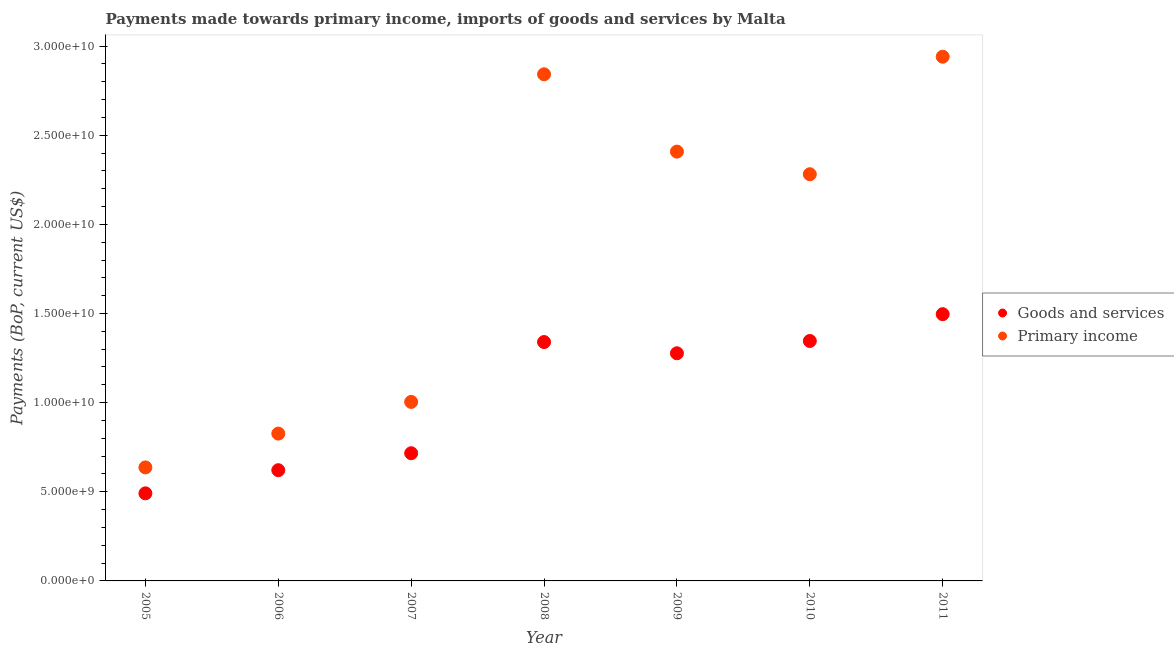Is the number of dotlines equal to the number of legend labels?
Make the answer very short. Yes. What is the payments made towards goods and services in 2008?
Ensure brevity in your answer.  1.34e+1. Across all years, what is the maximum payments made towards goods and services?
Offer a terse response. 1.50e+1. Across all years, what is the minimum payments made towards primary income?
Offer a terse response. 6.37e+09. In which year was the payments made towards primary income minimum?
Ensure brevity in your answer.  2005. What is the total payments made towards goods and services in the graph?
Provide a succinct answer. 7.29e+1. What is the difference between the payments made towards goods and services in 2005 and that in 2008?
Your answer should be very brief. -8.49e+09. What is the difference between the payments made towards goods and services in 2011 and the payments made towards primary income in 2007?
Ensure brevity in your answer.  4.92e+09. What is the average payments made towards goods and services per year?
Keep it short and to the point. 1.04e+1. In the year 2006, what is the difference between the payments made towards goods and services and payments made towards primary income?
Ensure brevity in your answer.  -2.05e+09. In how many years, is the payments made towards primary income greater than 17000000000 US$?
Offer a terse response. 4. What is the ratio of the payments made towards primary income in 2005 to that in 2010?
Keep it short and to the point. 0.28. What is the difference between the highest and the second highest payments made towards goods and services?
Your answer should be very brief. 1.50e+09. What is the difference between the highest and the lowest payments made towards goods and services?
Your answer should be compact. 1.00e+1. In how many years, is the payments made towards primary income greater than the average payments made towards primary income taken over all years?
Offer a very short reply. 4. Is the payments made towards primary income strictly greater than the payments made towards goods and services over the years?
Your response must be concise. Yes. Is the payments made towards goods and services strictly less than the payments made towards primary income over the years?
Ensure brevity in your answer.  Yes. Does the graph contain any zero values?
Your response must be concise. No. Does the graph contain grids?
Keep it short and to the point. No. Where does the legend appear in the graph?
Your response must be concise. Center right. How many legend labels are there?
Ensure brevity in your answer.  2. How are the legend labels stacked?
Keep it short and to the point. Vertical. What is the title of the graph?
Ensure brevity in your answer.  Payments made towards primary income, imports of goods and services by Malta. Does "Official aid received" appear as one of the legend labels in the graph?
Ensure brevity in your answer.  No. What is the label or title of the Y-axis?
Your answer should be very brief. Payments (BoP, current US$). What is the Payments (BoP, current US$) in Goods and services in 2005?
Your answer should be compact. 4.91e+09. What is the Payments (BoP, current US$) in Primary income in 2005?
Keep it short and to the point. 6.37e+09. What is the Payments (BoP, current US$) in Goods and services in 2006?
Ensure brevity in your answer.  6.21e+09. What is the Payments (BoP, current US$) in Primary income in 2006?
Offer a terse response. 8.26e+09. What is the Payments (BoP, current US$) of Goods and services in 2007?
Your answer should be compact. 7.16e+09. What is the Payments (BoP, current US$) of Primary income in 2007?
Offer a very short reply. 1.00e+1. What is the Payments (BoP, current US$) in Goods and services in 2008?
Keep it short and to the point. 1.34e+1. What is the Payments (BoP, current US$) of Primary income in 2008?
Give a very brief answer. 2.84e+1. What is the Payments (BoP, current US$) of Goods and services in 2009?
Offer a very short reply. 1.28e+1. What is the Payments (BoP, current US$) in Primary income in 2009?
Keep it short and to the point. 2.41e+1. What is the Payments (BoP, current US$) in Goods and services in 2010?
Keep it short and to the point. 1.35e+1. What is the Payments (BoP, current US$) of Primary income in 2010?
Your answer should be very brief. 2.28e+1. What is the Payments (BoP, current US$) in Goods and services in 2011?
Your answer should be compact. 1.50e+1. What is the Payments (BoP, current US$) in Primary income in 2011?
Provide a succinct answer. 2.94e+1. Across all years, what is the maximum Payments (BoP, current US$) of Goods and services?
Give a very brief answer. 1.50e+1. Across all years, what is the maximum Payments (BoP, current US$) in Primary income?
Provide a short and direct response. 2.94e+1. Across all years, what is the minimum Payments (BoP, current US$) of Goods and services?
Provide a succinct answer. 4.91e+09. Across all years, what is the minimum Payments (BoP, current US$) of Primary income?
Offer a terse response. 6.37e+09. What is the total Payments (BoP, current US$) of Goods and services in the graph?
Your response must be concise. 7.29e+1. What is the total Payments (BoP, current US$) of Primary income in the graph?
Give a very brief answer. 1.29e+11. What is the difference between the Payments (BoP, current US$) of Goods and services in 2005 and that in 2006?
Offer a terse response. -1.30e+09. What is the difference between the Payments (BoP, current US$) of Primary income in 2005 and that in 2006?
Your response must be concise. -1.90e+09. What is the difference between the Payments (BoP, current US$) in Goods and services in 2005 and that in 2007?
Make the answer very short. -2.25e+09. What is the difference between the Payments (BoP, current US$) of Primary income in 2005 and that in 2007?
Give a very brief answer. -3.67e+09. What is the difference between the Payments (BoP, current US$) in Goods and services in 2005 and that in 2008?
Provide a short and direct response. -8.49e+09. What is the difference between the Payments (BoP, current US$) of Primary income in 2005 and that in 2008?
Offer a very short reply. -2.21e+1. What is the difference between the Payments (BoP, current US$) in Goods and services in 2005 and that in 2009?
Provide a short and direct response. -7.86e+09. What is the difference between the Payments (BoP, current US$) of Primary income in 2005 and that in 2009?
Keep it short and to the point. -1.77e+1. What is the difference between the Payments (BoP, current US$) in Goods and services in 2005 and that in 2010?
Offer a terse response. -8.55e+09. What is the difference between the Payments (BoP, current US$) in Primary income in 2005 and that in 2010?
Your answer should be very brief. -1.64e+1. What is the difference between the Payments (BoP, current US$) in Goods and services in 2005 and that in 2011?
Provide a succinct answer. -1.00e+1. What is the difference between the Payments (BoP, current US$) of Primary income in 2005 and that in 2011?
Your answer should be compact. -2.30e+1. What is the difference between the Payments (BoP, current US$) in Goods and services in 2006 and that in 2007?
Your answer should be very brief. -9.52e+08. What is the difference between the Payments (BoP, current US$) of Primary income in 2006 and that in 2007?
Ensure brevity in your answer.  -1.78e+09. What is the difference between the Payments (BoP, current US$) in Goods and services in 2006 and that in 2008?
Provide a succinct answer. -7.19e+09. What is the difference between the Payments (BoP, current US$) in Primary income in 2006 and that in 2008?
Your answer should be very brief. -2.02e+1. What is the difference between the Payments (BoP, current US$) of Goods and services in 2006 and that in 2009?
Offer a terse response. -6.56e+09. What is the difference between the Payments (BoP, current US$) in Primary income in 2006 and that in 2009?
Make the answer very short. -1.58e+1. What is the difference between the Payments (BoP, current US$) of Goods and services in 2006 and that in 2010?
Offer a very short reply. -7.25e+09. What is the difference between the Payments (BoP, current US$) in Primary income in 2006 and that in 2010?
Offer a terse response. -1.45e+1. What is the difference between the Payments (BoP, current US$) of Goods and services in 2006 and that in 2011?
Offer a terse response. -8.75e+09. What is the difference between the Payments (BoP, current US$) in Primary income in 2006 and that in 2011?
Your response must be concise. -2.11e+1. What is the difference between the Payments (BoP, current US$) in Goods and services in 2007 and that in 2008?
Give a very brief answer. -6.24e+09. What is the difference between the Payments (BoP, current US$) of Primary income in 2007 and that in 2008?
Offer a terse response. -1.84e+1. What is the difference between the Payments (BoP, current US$) of Goods and services in 2007 and that in 2009?
Ensure brevity in your answer.  -5.61e+09. What is the difference between the Payments (BoP, current US$) in Primary income in 2007 and that in 2009?
Make the answer very short. -1.40e+1. What is the difference between the Payments (BoP, current US$) in Goods and services in 2007 and that in 2010?
Offer a very short reply. -6.30e+09. What is the difference between the Payments (BoP, current US$) of Primary income in 2007 and that in 2010?
Keep it short and to the point. -1.28e+1. What is the difference between the Payments (BoP, current US$) of Goods and services in 2007 and that in 2011?
Give a very brief answer. -7.80e+09. What is the difference between the Payments (BoP, current US$) of Primary income in 2007 and that in 2011?
Ensure brevity in your answer.  -1.94e+1. What is the difference between the Payments (BoP, current US$) of Goods and services in 2008 and that in 2009?
Ensure brevity in your answer.  6.31e+08. What is the difference between the Payments (BoP, current US$) of Primary income in 2008 and that in 2009?
Your response must be concise. 4.34e+09. What is the difference between the Payments (BoP, current US$) in Goods and services in 2008 and that in 2010?
Your response must be concise. -5.88e+07. What is the difference between the Payments (BoP, current US$) of Primary income in 2008 and that in 2010?
Provide a short and direct response. 5.61e+09. What is the difference between the Payments (BoP, current US$) in Goods and services in 2008 and that in 2011?
Your answer should be very brief. -1.56e+09. What is the difference between the Payments (BoP, current US$) in Primary income in 2008 and that in 2011?
Ensure brevity in your answer.  -9.86e+08. What is the difference between the Payments (BoP, current US$) in Goods and services in 2009 and that in 2010?
Ensure brevity in your answer.  -6.89e+08. What is the difference between the Payments (BoP, current US$) in Primary income in 2009 and that in 2010?
Give a very brief answer. 1.27e+09. What is the difference between the Payments (BoP, current US$) in Goods and services in 2009 and that in 2011?
Provide a succinct answer. -2.19e+09. What is the difference between the Payments (BoP, current US$) in Primary income in 2009 and that in 2011?
Offer a very short reply. -5.32e+09. What is the difference between the Payments (BoP, current US$) of Goods and services in 2010 and that in 2011?
Provide a short and direct response. -1.50e+09. What is the difference between the Payments (BoP, current US$) in Primary income in 2010 and that in 2011?
Your answer should be compact. -6.59e+09. What is the difference between the Payments (BoP, current US$) of Goods and services in 2005 and the Payments (BoP, current US$) of Primary income in 2006?
Give a very brief answer. -3.35e+09. What is the difference between the Payments (BoP, current US$) in Goods and services in 2005 and the Payments (BoP, current US$) in Primary income in 2007?
Keep it short and to the point. -5.13e+09. What is the difference between the Payments (BoP, current US$) in Goods and services in 2005 and the Payments (BoP, current US$) in Primary income in 2008?
Ensure brevity in your answer.  -2.35e+1. What is the difference between the Payments (BoP, current US$) of Goods and services in 2005 and the Payments (BoP, current US$) of Primary income in 2009?
Provide a succinct answer. -1.92e+1. What is the difference between the Payments (BoP, current US$) of Goods and services in 2005 and the Payments (BoP, current US$) of Primary income in 2010?
Your answer should be compact. -1.79e+1. What is the difference between the Payments (BoP, current US$) of Goods and services in 2005 and the Payments (BoP, current US$) of Primary income in 2011?
Your answer should be very brief. -2.45e+1. What is the difference between the Payments (BoP, current US$) of Goods and services in 2006 and the Payments (BoP, current US$) of Primary income in 2007?
Offer a very short reply. -3.83e+09. What is the difference between the Payments (BoP, current US$) of Goods and services in 2006 and the Payments (BoP, current US$) of Primary income in 2008?
Provide a succinct answer. -2.22e+1. What is the difference between the Payments (BoP, current US$) of Goods and services in 2006 and the Payments (BoP, current US$) of Primary income in 2009?
Provide a short and direct response. -1.79e+1. What is the difference between the Payments (BoP, current US$) of Goods and services in 2006 and the Payments (BoP, current US$) of Primary income in 2010?
Provide a succinct answer. -1.66e+1. What is the difference between the Payments (BoP, current US$) of Goods and services in 2006 and the Payments (BoP, current US$) of Primary income in 2011?
Provide a short and direct response. -2.32e+1. What is the difference between the Payments (BoP, current US$) in Goods and services in 2007 and the Payments (BoP, current US$) in Primary income in 2008?
Your answer should be compact. -2.13e+1. What is the difference between the Payments (BoP, current US$) in Goods and services in 2007 and the Payments (BoP, current US$) in Primary income in 2009?
Your answer should be compact. -1.69e+1. What is the difference between the Payments (BoP, current US$) of Goods and services in 2007 and the Payments (BoP, current US$) of Primary income in 2010?
Keep it short and to the point. -1.56e+1. What is the difference between the Payments (BoP, current US$) in Goods and services in 2007 and the Payments (BoP, current US$) in Primary income in 2011?
Offer a terse response. -2.22e+1. What is the difference between the Payments (BoP, current US$) in Goods and services in 2008 and the Payments (BoP, current US$) in Primary income in 2009?
Your answer should be very brief. -1.07e+1. What is the difference between the Payments (BoP, current US$) of Goods and services in 2008 and the Payments (BoP, current US$) of Primary income in 2010?
Ensure brevity in your answer.  -9.41e+09. What is the difference between the Payments (BoP, current US$) of Goods and services in 2008 and the Payments (BoP, current US$) of Primary income in 2011?
Provide a succinct answer. -1.60e+1. What is the difference between the Payments (BoP, current US$) in Goods and services in 2009 and the Payments (BoP, current US$) in Primary income in 2010?
Ensure brevity in your answer.  -1.00e+1. What is the difference between the Payments (BoP, current US$) in Goods and services in 2009 and the Payments (BoP, current US$) in Primary income in 2011?
Offer a very short reply. -1.66e+1. What is the difference between the Payments (BoP, current US$) in Goods and services in 2010 and the Payments (BoP, current US$) in Primary income in 2011?
Provide a succinct answer. -1.59e+1. What is the average Payments (BoP, current US$) of Goods and services per year?
Offer a very short reply. 1.04e+1. What is the average Payments (BoP, current US$) in Primary income per year?
Give a very brief answer. 1.85e+1. In the year 2005, what is the difference between the Payments (BoP, current US$) in Goods and services and Payments (BoP, current US$) in Primary income?
Offer a very short reply. -1.45e+09. In the year 2006, what is the difference between the Payments (BoP, current US$) of Goods and services and Payments (BoP, current US$) of Primary income?
Offer a terse response. -2.05e+09. In the year 2007, what is the difference between the Payments (BoP, current US$) of Goods and services and Payments (BoP, current US$) of Primary income?
Make the answer very short. -2.88e+09. In the year 2008, what is the difference between the Payments (BoP, current US$) in Goods and services and Payments (BoP, current US$) in Primary income?
Provide a succinct answer. -1.50e+1. In the year 2009, what is the difference between the Payments (BoP, current US$) of Goods and services and Payments (BoP, current US$) of Primary income?
Offer a very short reply. -1.13e+1. In the year 2010, what is the difference between the Payments (BoP, current US$) of Goods and services and Payments (BoP, current US$) of Primary income?
Your answer should be very brief. -9.35e+09. In the year 2011, what is the difference between the Payments (BoP, current US$) in Goods and services and Payments (BoP, current US$) in Primary income?
Offer a very short reply. -1.44e+1. What is the ratio of the Payments (BoP, current US$) in Goods and services in 2005 to that in 2006?
Your response must be concise. 0.79. What is the ratio of the Payments (BoP, current US$) in Primary income in 2005 to that in 2006?
Provide a succinct answer. 0.77. What is the ratio of the Payments (BoP, current US$) in Goods and services in 2005 to that in 2007?
Your response must be concise. 0.69. What is the ratio of the Payments (BoP, current US$) of Primary income in 2005 to that in 2007?
Keep it short and to the point. 0.63. What is the ratio of the Payments (BoP, current US$) in Goods and services in 2005 to that in 2008?
Make the answer very short. 0.37. What is the ratio of the Payments (BoP, current US$) of Primary income in 2005 to that in 2008?
Your answer should be compact. 0.22. What is the ratio of the Payments (BoP, current US$) of Goods and services in 2005 to that in 2009?
Ensure brevity in your answer.  0.38. What is the ratio of the Payments (BoP, current US$) in Primary income in 2005 to that in 2009?
Ensure brevity in your answer.  0.26. What is the ratio of the Payments (BoP, current US$) of Goods and services in 2005 to that in 2010?
Provide a short and direct response. 0.36. What is the ratio of the Payments (BoP, current US$) of Primary income in 2005 to that in 2010?
Provide a succinct answer. 0.28. What is the ratio of the Payments (BoP, current US$) in Goods and services in 2005 to that in 2011?
Keep it short and to the point. 0.33. What is the ratio of the Payments (BoP, current US$) in Primary income in 2005 to that in 2011?
Ensure brevity in your answer.  0.22. What is the ratio of the Payments (BoP, current US$) of Goods and services in 2006 to that in 2007?
Give a very brief answer. 0.87. What is the ratio of the Payments (BoP, current US$) of Primary income in 2006 to that in 2007?
Keep it short and to the point. 0.82. What is the ratio of the Payments (BoP, current US$) of Goods and services in 2006 to that in 2008?
Your answer should be very brief. 0.46. What is the ratio of the Payments (BoP, current US$) in Primary income in 2006 to that in 2008?
Offer a terse response. 0.29. What is the ratio of the Payments (BoP, current US$) in Goods and services in 2006 to that in 2009?
Offer a terse response. 0.49. What is the ratio of the Payments (BoP, current US$) in Primary income in 2006 to that in 2009?
Give a very brief answer. 0.34. What is the ratio of the Payments (BoP, current US$) in Goods and services in 2006 to that in 2010?
Provide a succinct answer. 0.46. What is the ratio of the Payments (BoP, current US$) in Primary income in 2006 to that in 2010?
Provide a succinct answer. 0.36. What is the ratio of the Payments (BoP, current US$) of Goods and services in 2006 to that in 2011?
Provide a short and direct response. 0.42. What is the ratio of the Payments (BoP, current US$) of Primary income in 2006 to that in 2011?
Make the answer very short. 0.28. What is the ratio of the Payments (BoP, current US$) of Goods and services in 2007 to that in 2008?
Provide a succinct answer. 0.53. What is the ratio of the Payments (BoP, current US$) in Primary income in 2007 to that in 2008?
Provide a succinct answer. 0.35. What is the ratio of the Payments (BoP, current US$) of Goods and services in 2007 to that in 2009?
Provide a succinct answer. 0.56. What is the ratio of the Payments (BoP, current US$) in Primary income in 2007 to that in 2009?
Provide a short and direct response. 0.42. What is the ratio of the Payments (BoP, current US$) of Goods and services in 2007 to that in 2010?
Your answer should be compact. 0.53. What is the ratio of the Payments (BoP, current US$) of Primary income in 2007 to that in 2010?
Keep it short and to the point. 0.44. What is the ratio of the Payments (BoP, current US$) of Goods and services in 2007 to that in 2011?
Your response must be concise. 0.48. What is the ratio of the Payments (BoP, current US$) in Primary income in 2007 to that in 2011?
Offer a very short reply. 0.34. What is the ratio of the Payments (BoP, current US$) of Goods and services in 2008 to that in 2009?
Offer a very short reply. 1.05. What is the ratio of the Payments (BoP, current US$) of Primary income in 2008 to that in 2009?
Keep it short and to the point. 1.18. What is the ratio of the Payments (BoP, current US$) in Goods and services in 2008 to that in 2010?
Give a very brief answer. 1. What is the ratio of the Payments (BoP, current US$) in Primary income in 2008 to that in 2010?
Offer a terse response. 1.25. What is the ratio of the Payments (BoP, current US$) in Goods and services in 2008 to that in 2011?
Provide a short and direct response. 0.9. What is the ratio of the Payments (BoP, current US$) in Primary income in 2008 to that in 2011?
Provide a short and direct response. 0.97. What is the ratio of the Payments (BoP, current US$) in Goods and services in 2009 to that in 2010?
Your answer should be compact. 0.95. What is the ratio of the Payments (BoP, current US$) in Primary income in 2009 to that in 2010?
Provide a short and direct response. 1.06. What is the ratio of the Payments (BoP, current US$) in Goods and services in 2009 to that in 2011?
Offer a very short reply. 0.85. What is the ratio of the Payments (BoP, current US$) in Primary income in 2009 to that in 2011?
Keep it short and to the point. 0.82. What is the ratio of the Payments (BoP, current US$) of Goods and services in 2010 to that in 2011?
Make the answer very short. 0.9. What is the ratio of the Payments (BoP, current US$) of Primary income in 2010 to that in 2011?
Your answer should be compact. 0.78. What is the difference between the highest and the second highest Payments (BoP, current US$) in Goods and services?
Make the answer very short. 1.50e+09. What is the difference between the highest and the second highest Payments (BoP, current US$) in Primary income?
Provide a succinct answer. 9.86e+08. What is the difference between the highest and the lowest Payments (BoP, current US$) of Goods and services?
Keep it short and to the point. 1.00e+1. What is the difference between the highest and the lowest Payments (BoP, current US$) of Primary income?
Keep it short and to the point. 2.30e+1. 